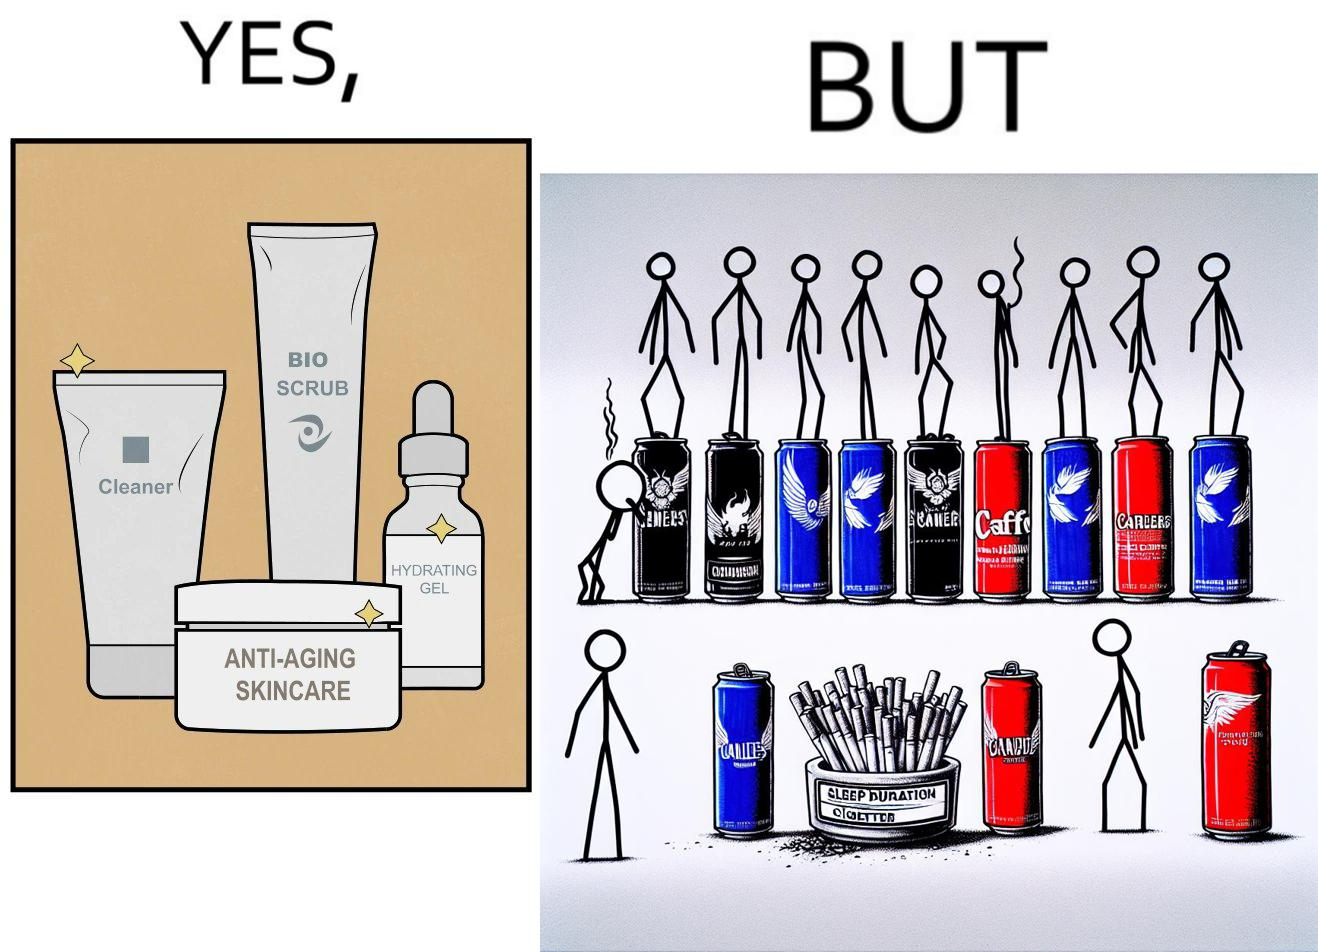Is this image satirical or non-satirical? Yes, this image is satirical. 